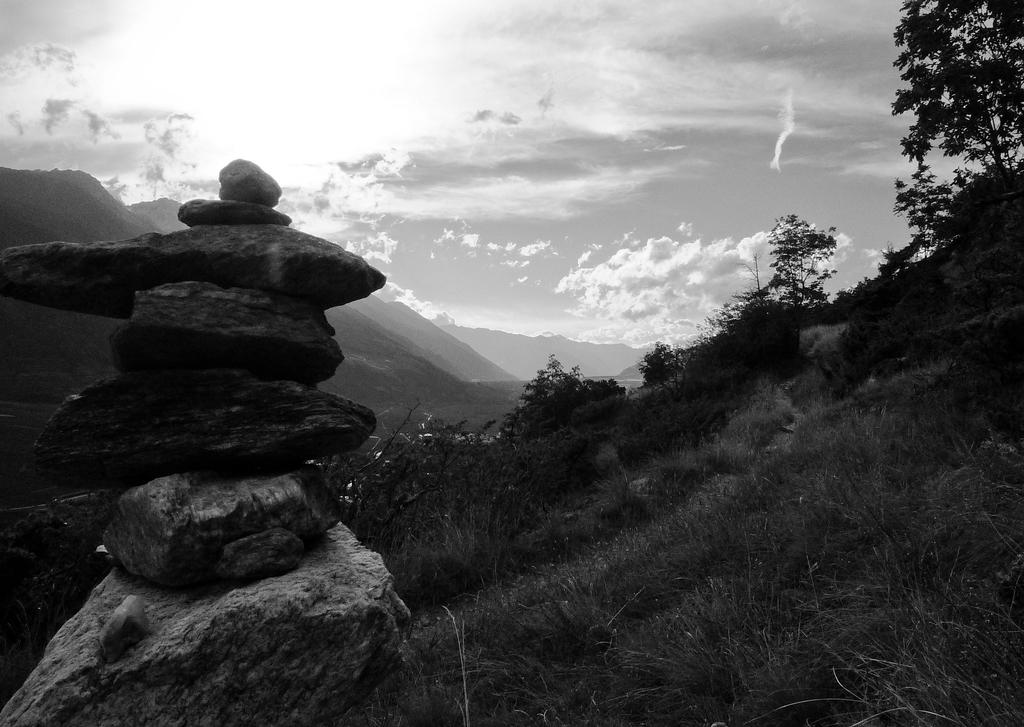What type of natural landform can be seen in the image? There are mountains in the image. What type of vegetation is present in the image? There are trees and grass in the image. What other objects can be seen on the ground in the image? There are stones in the image. What is visible in the background of the image? The sky is visible in the image. What is the color scheme of the image? The image is in black and white. Where is the faucet located in the image? There is no faucet present in the image. What type of paste is used to create the image? The image is in black and white, so there is no paste used to create it. 